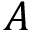Convert formula to latex. <formula><loc_0><loc_0><loc_500><loc_500>A</formula> 